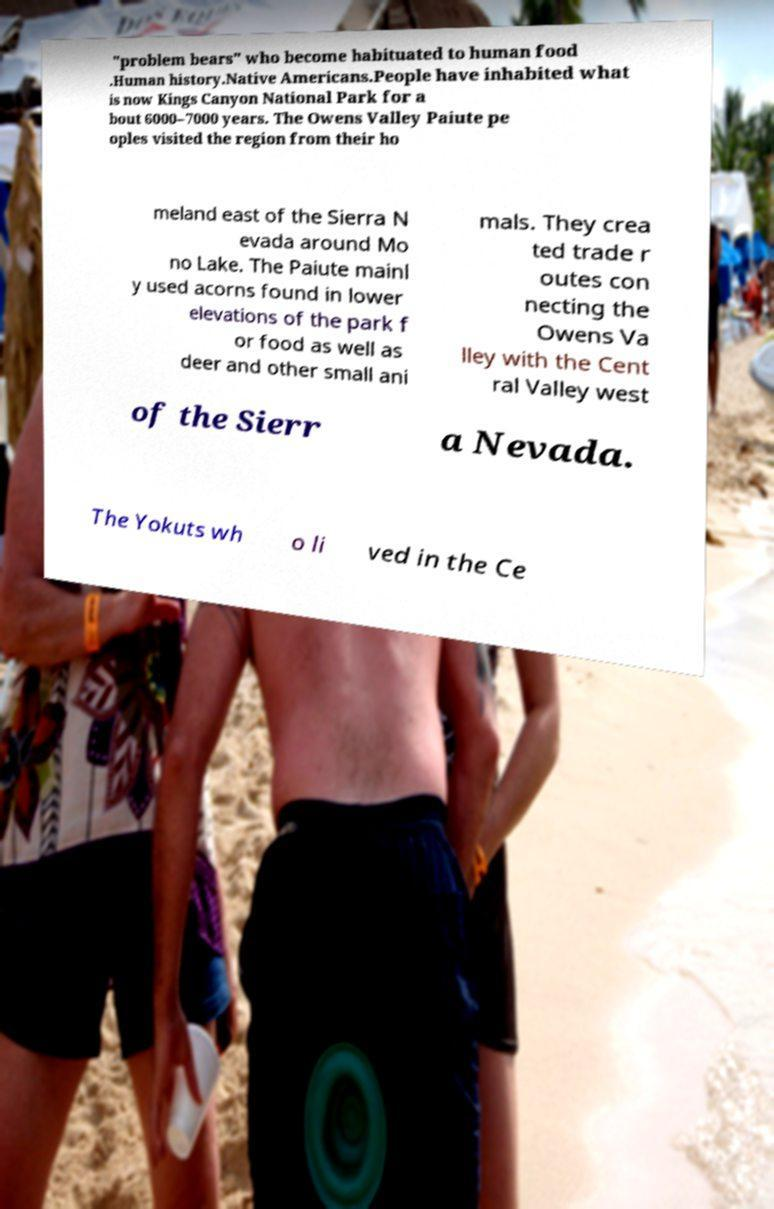What messages or text are displayed in this image? I need them in a readable, typed format. "problem bears" who become habituated to human food .Human history.Native Americans.People have inhabited what is now Kings Canyon National Park for a bout 6000–7000 years. The Owens Valley Paiute pe oples visited the region from their ho meland east of the Sierra N evada around Mo no Lake. The Paiute mainl y used acorns found in lower elevations of the park f or food as well as deer and other small ani mals. They crea ted trade r outes con necting the Owens Va lley with the Cent ral Valley west of the Sierr a Nevada. The Yokuts wh o li ved in the Ce 